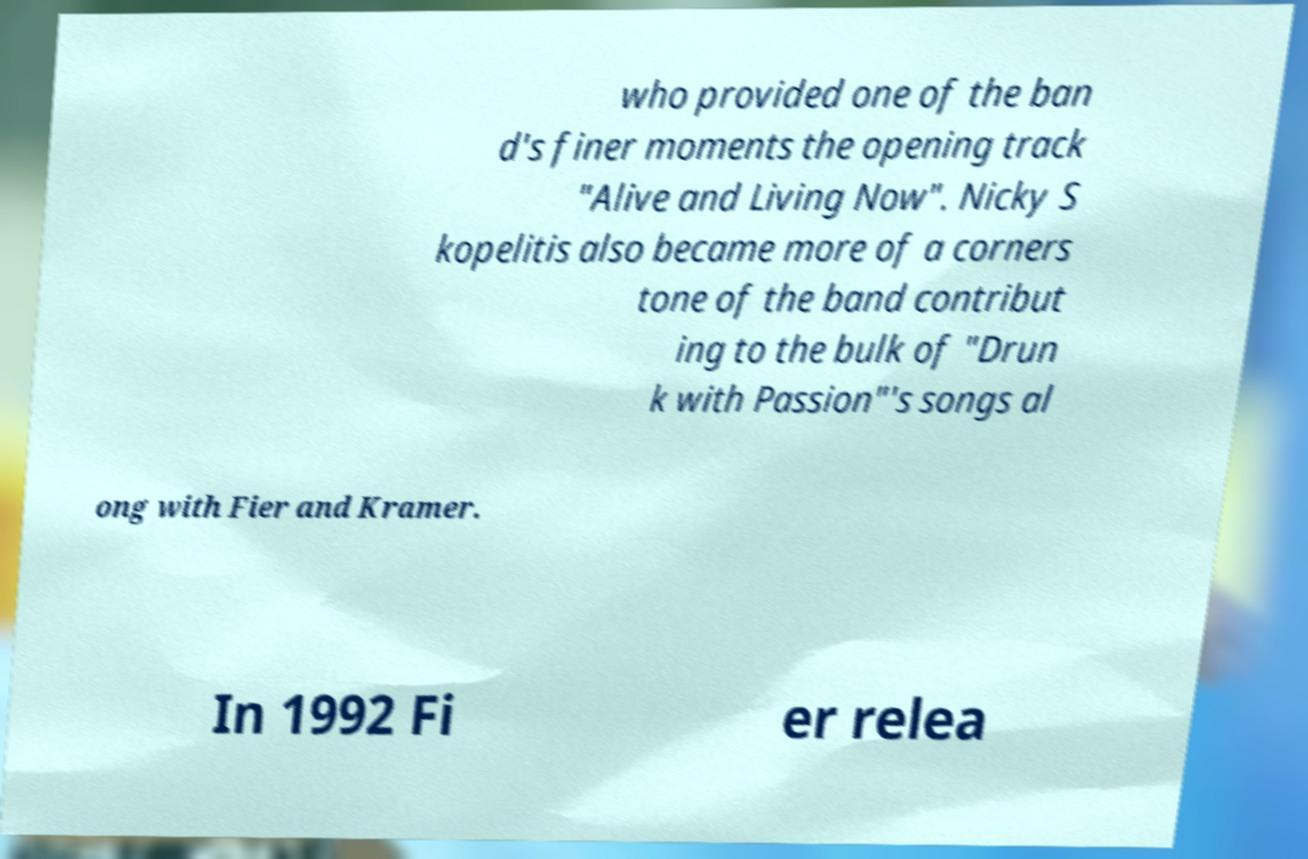Please read and relay the text visible in this image. What does it say? who provided one of the ban d's finer moments the opening track "Alive and Living Now". Nicky S kopelitis also became more of a corners tone of the band contribut ing to the bulk of "Drun k with Passion"'s songs al ong with Fier and Kramer. In 1992 Fi er relea 